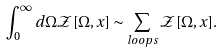Convert formula to latex. <formula><loc_0><loc_0><loc_500><loc_500>\int ^ { \infty } _ { 0 } d \Omega \mathcal { Z } [ \Omega , x ] \sim \sum _ { l o o p s } \mathcal { Z } [ \Omega , x ] .</formula> 